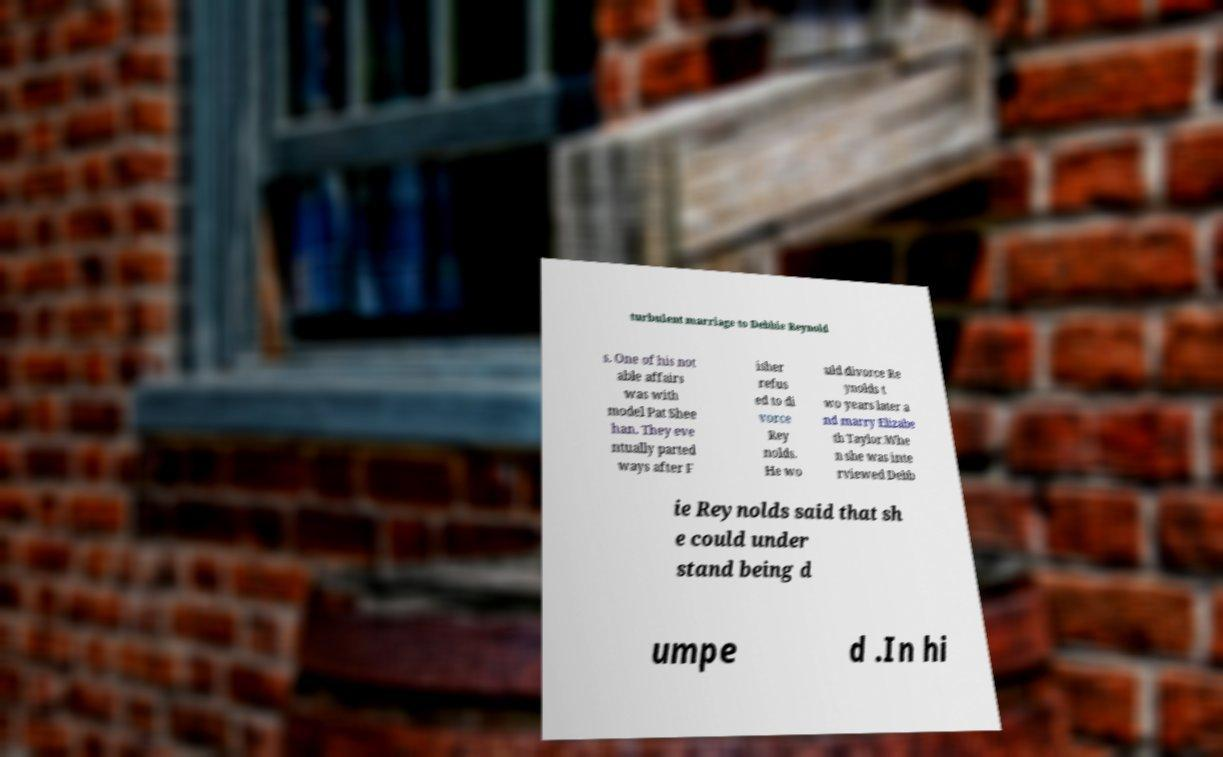Could you assist in decoding the text presented in this image and type it out clearly? turbulent marriage to Debbie Reynold s. One of his not able affairs was with model Pat Shee han. They eve ntually parted ways after F isher refus ed to di vorce Rey nolds. He wo uld divorce Re ynolds t wo years later a nd marry Elizabe th Taylor.Whe n she was inte rviewed Debb ie Reynolds said that sh e could under stand being d umpe d .In hi 